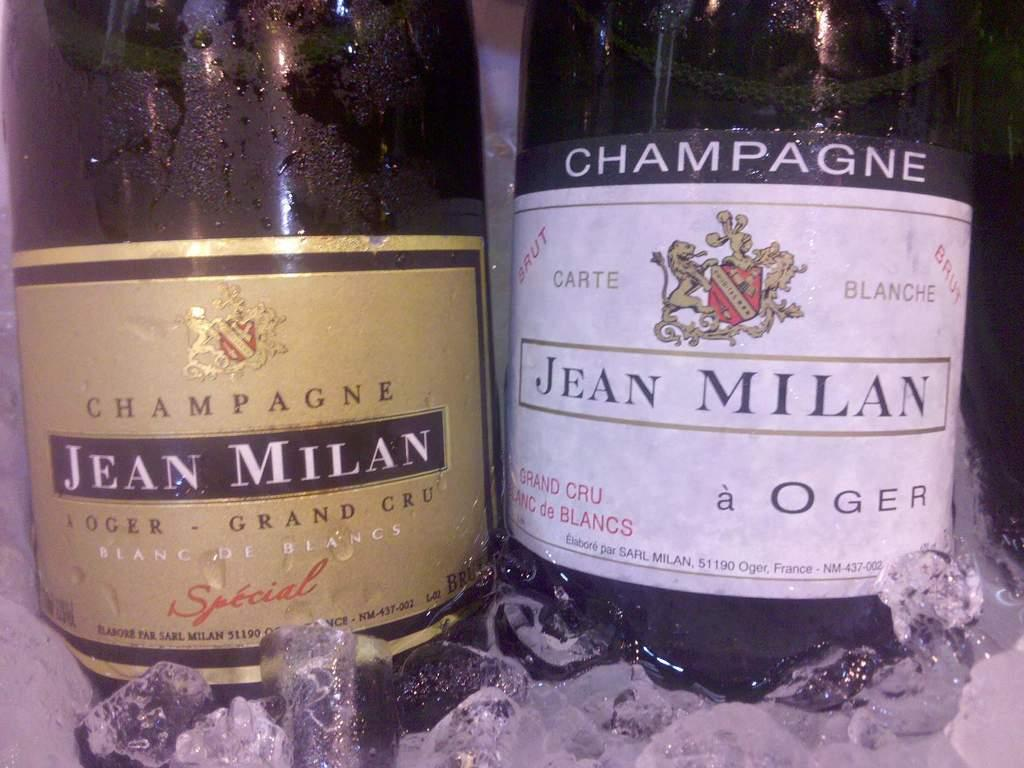How many wine bottles are visible in the image? There are two wine bottles in the image. What can be seen on the wine bottles? The wine bottles have a label. How are the wine bottles stored in the image? The wine bottles are kept in ice cubes. What type of popcorn is being served at the party in the image? There is no party or popcorn present in the image; it features two wine bottles kept in ice cubes. What is the engine used for in the image? There is no engine present in the image. 